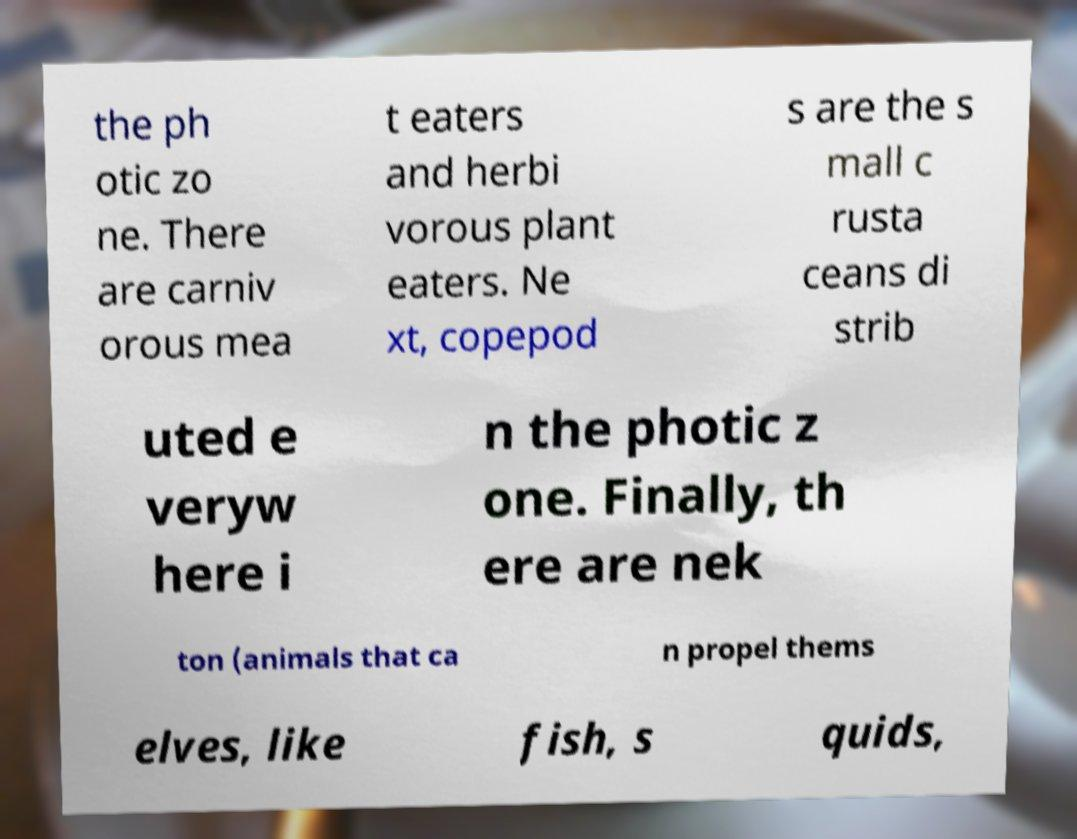Can you read and provide the text displayed in the image?This photo seems to have some interesting text. Can you extract and type it out for me? the ph otic zo ne. There are carniv orous mea t eaters and herbi vorous plant eaters. Ne xt, copepod s are the s mall c rusta ceans di strib uted e veryw here i n the photic z one. Finally, th ere are nek ton (animals that ca n propel thems elves, like fish, s quids, 